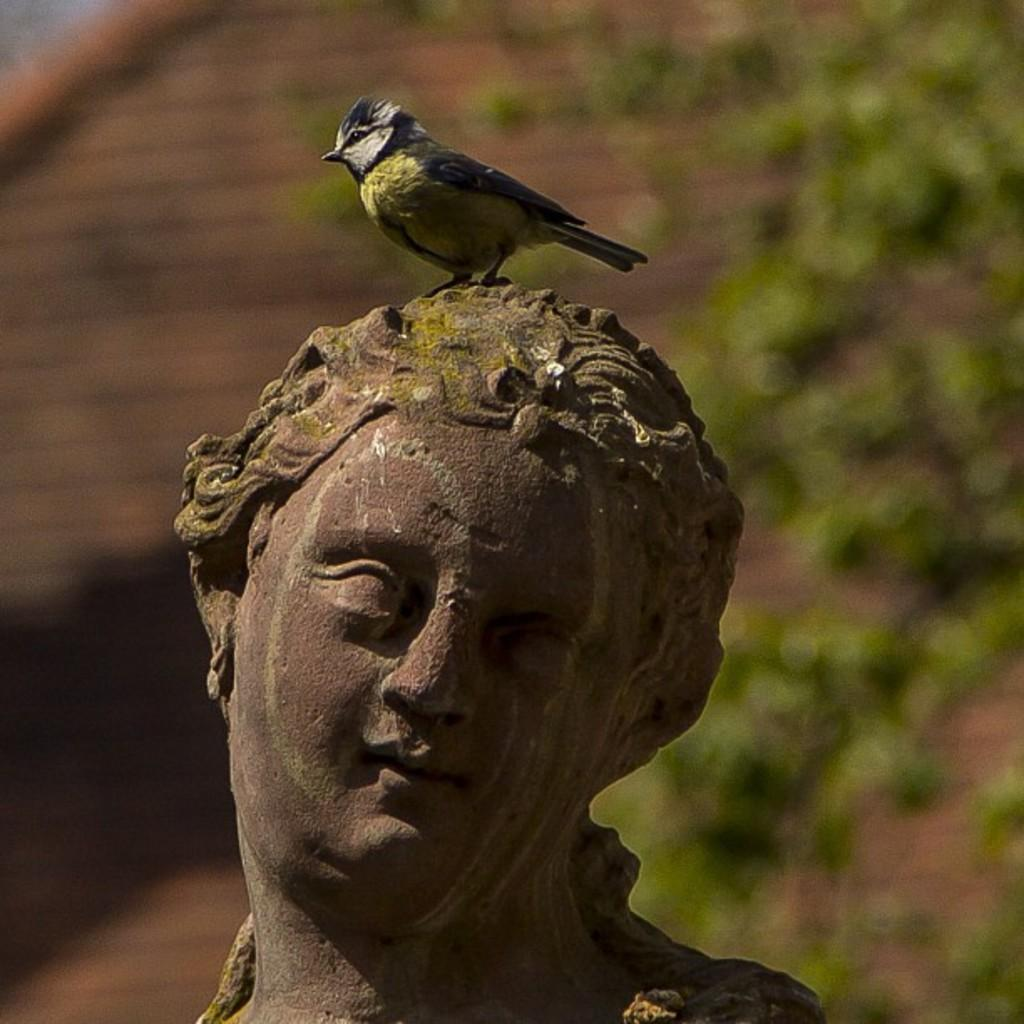What is the main subject of the image? The main subject of the image is a bird on a statue. Can you describe the bird's position or posture? The provided facts do not mention the bird's position or posture. What type of statue is the bird perched on? The provided facts do not specify the type of statue. What type of quartz is the bird using to whistle in the image? There is no quartz or whistling bird present in the image. How much fuel is required to power the bird's flight in the image? Birds do not require fuel to fly, and there is no bird in flight in the image. 